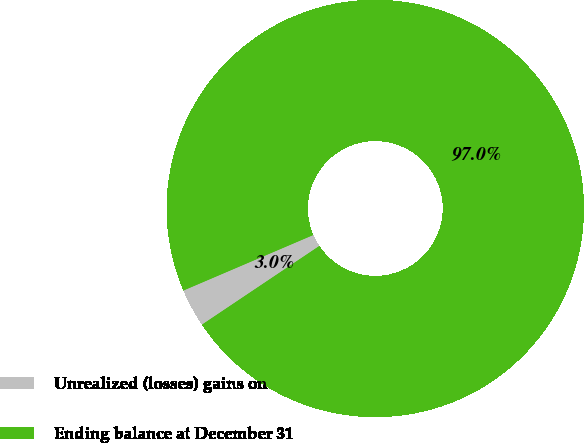<chart> <loc_0><loc_0><loc_500><loc_500><pie_chart><fcel>Unrealized (losses) gains on<fcel>Ending balance at December 31<nl><fcel>2.97%<fcel>97.03%<nl></chart> 